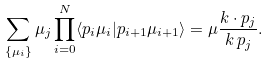<formula> <loc_0><loc_0><loc_500><loc_500>\sum _ { \{ \mu _ { i } \} } \mu _ { j } \prod _ { i = 0 } ^ { N } \langle { p } _ { i } \mu _ { i } | { p } _ { i + 1 } \mu _ { i + 1 } \rangle = \mu \frac { { k } \cdot { p } _ { j } } { k \, p _ { j } } .</formula> 